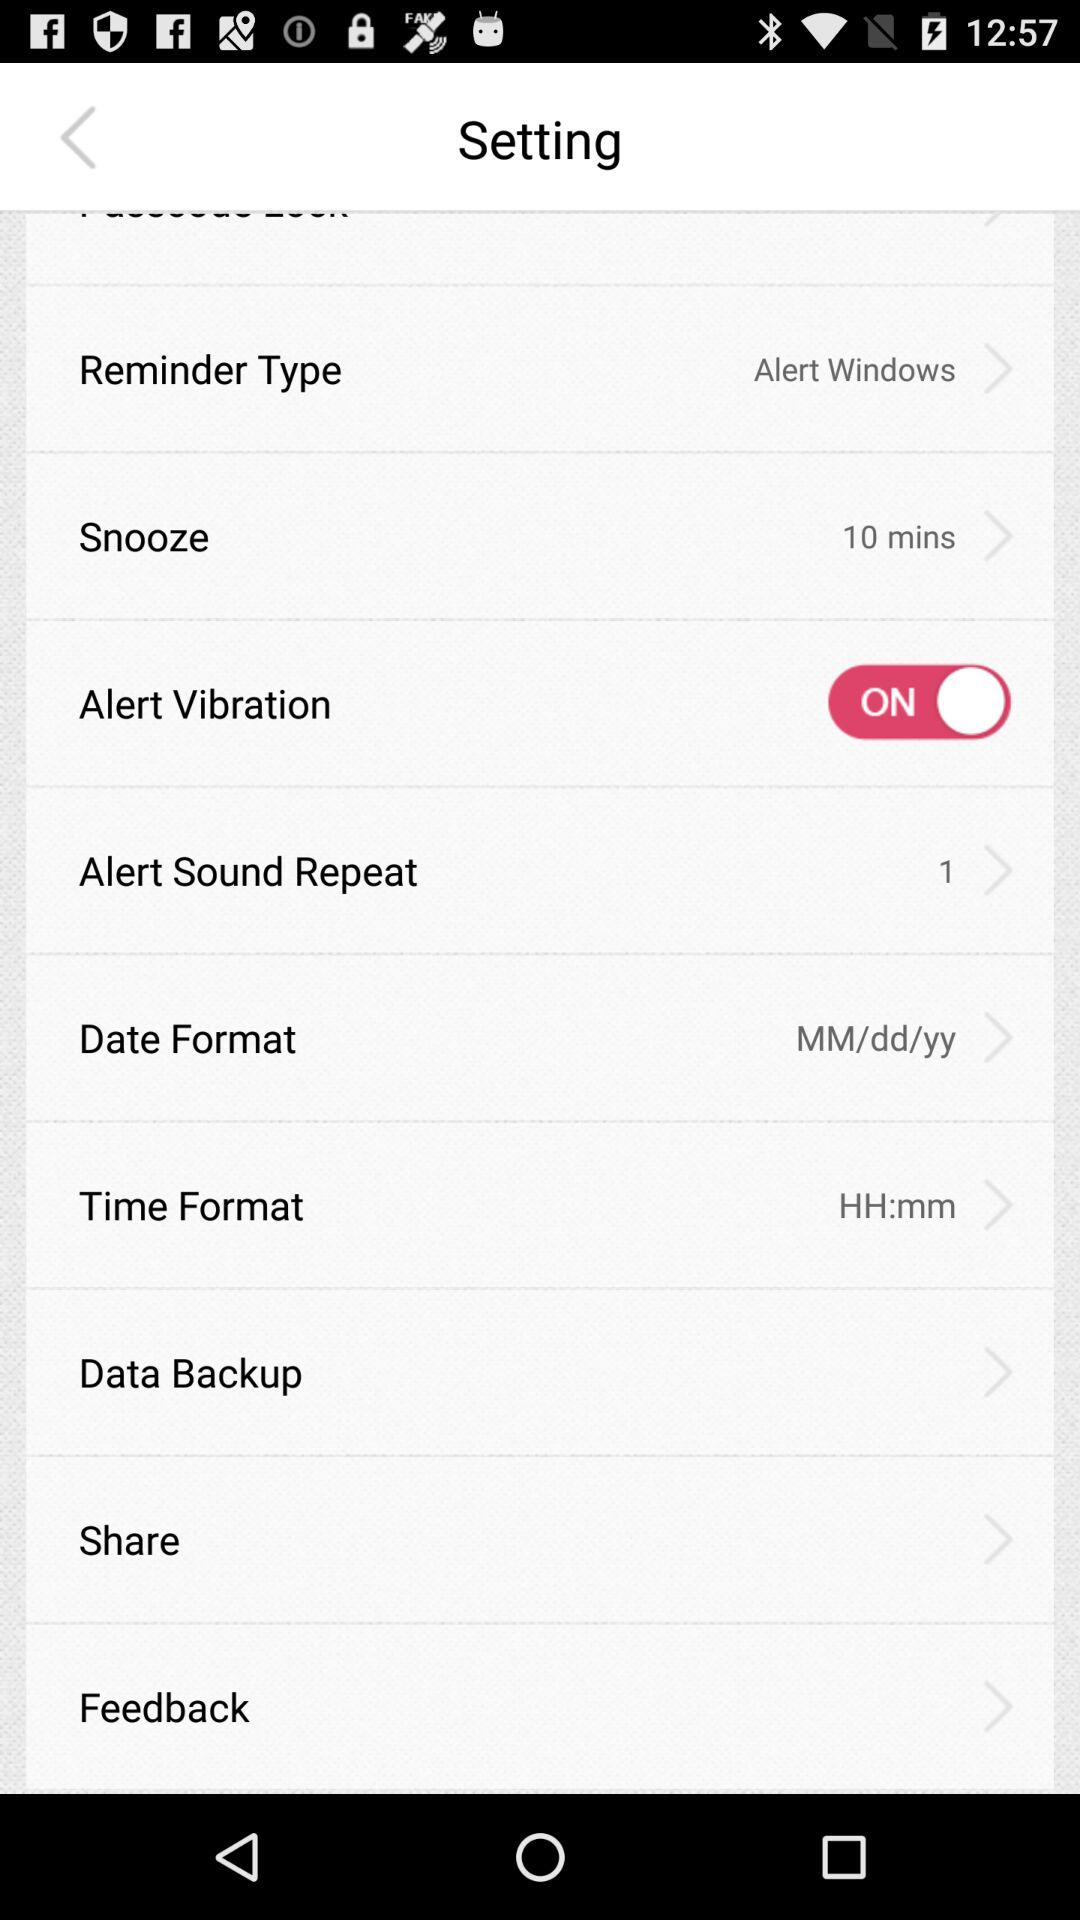How many times does the alert sound repeat? The alert sound repeats once. 